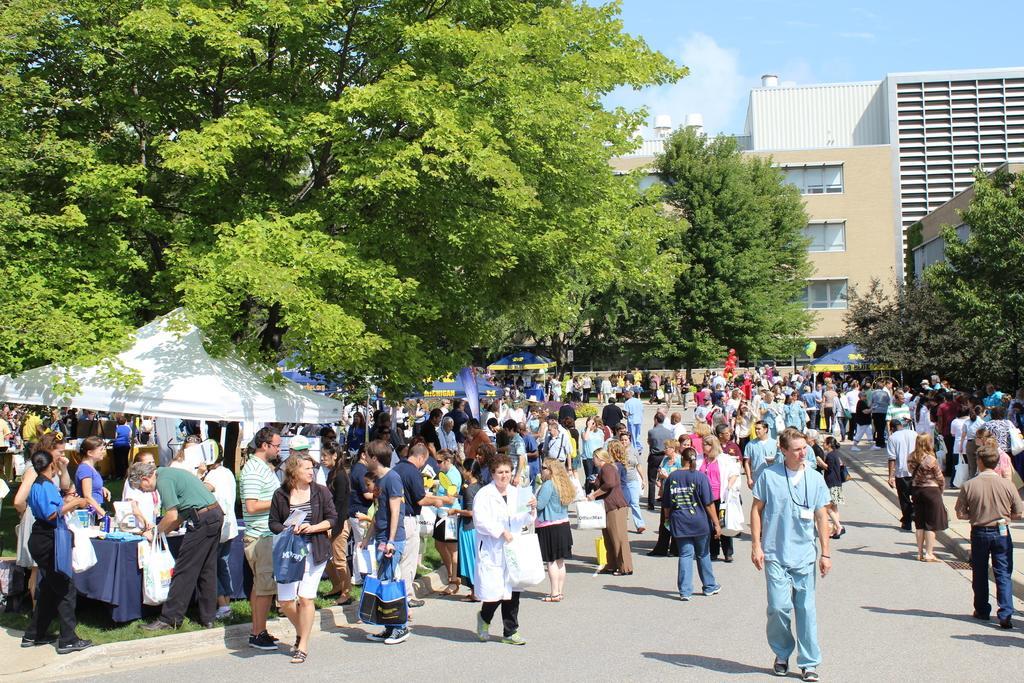How would you summarize this image in a sentence or two? In this image we can see people walking. On the left there are tents and we can see trees. In the background there is a building and sky. At the bottom there is a road. 